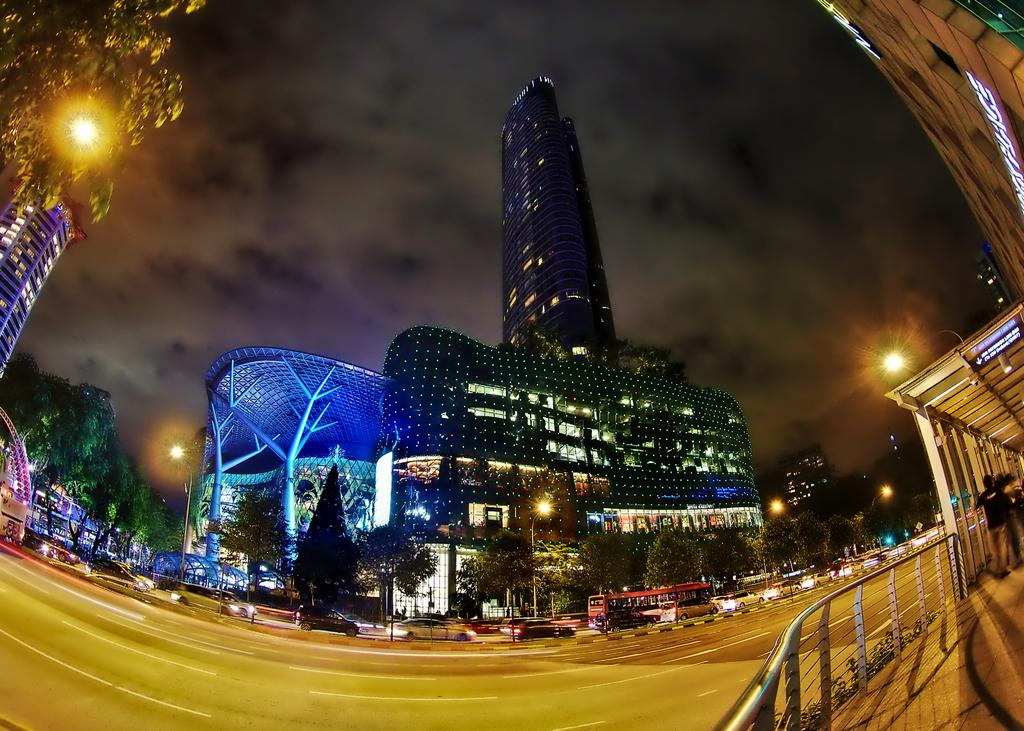What can be seen in the sky in the image? The sky with clouds is visible in the image. What type of natural vegetation is present in the image? There are trees in the image. What type of man-made structures are visible in the image? There are buildings in the image. What type of transportation is present on the road in the image? Motor vehicles are present on the road in the image. What type of street furniture is visible in the image? Street poles are visible in the image. What are the persons in the image doing? The persons are standing on the floor in the image, and they are holding grills. What type of additional structures are present in the image? There are sheds in the image. What type of breakfast is being served in the image? There is no breakfast visible in the image. What time of day is the image depicting? The time of day cannot be determined from the image, as there is no specific indication of day or night. 